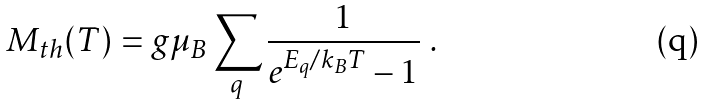<formula> <loc_0><loc_0><loc_500><loc_500>M _ { t h } ( T ) = g \mu _ { B } \sum _ { q } \frac { 1 } { e ^ { E _ { q } / k _ { B } T } - 1 } \ .</formula> 